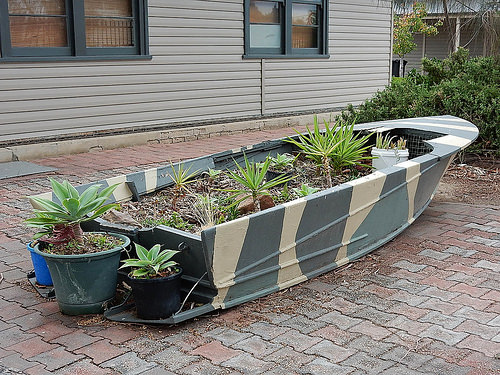<image>
Is there a house in front of the flower pot? No. The house is not in front of the flower pot. The spatial positioning shows a different relationship between these objects. 